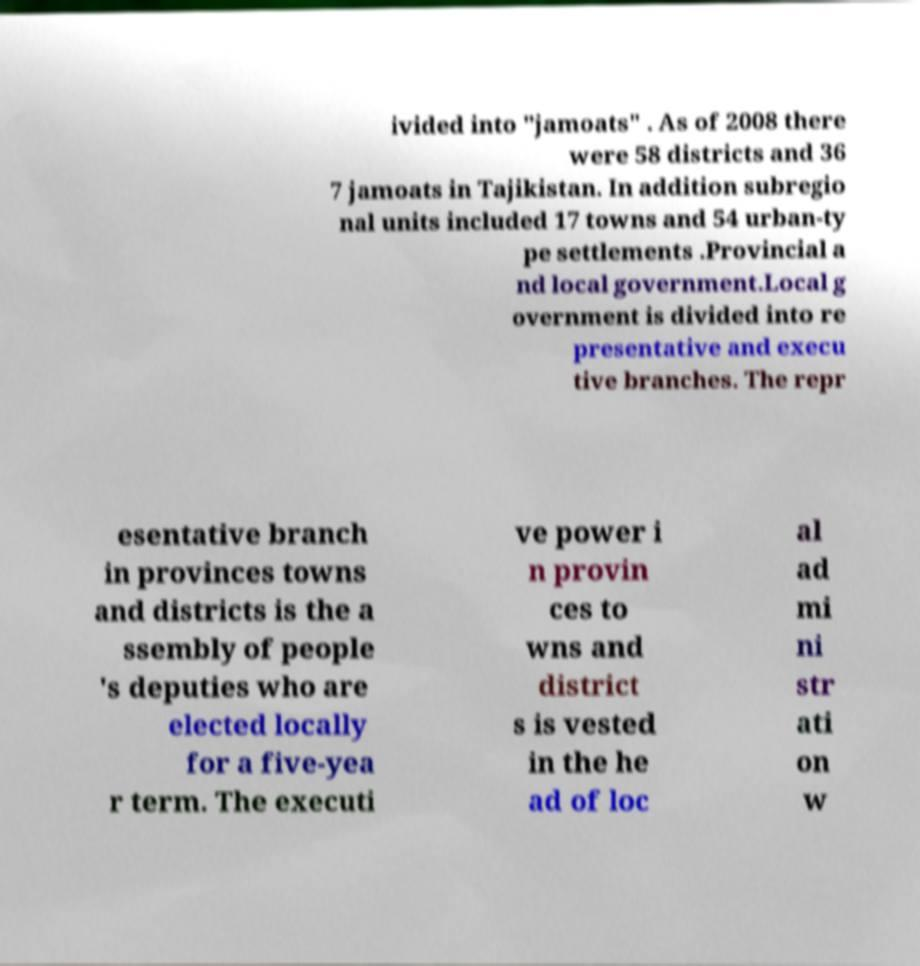Could you extract and type out the text from this image? ivided into "jamoats" . As of 2008 there were 58 districts and 36 7 jamoats in Tajikistan. In addition subregio nal units included 17 towns and 54 urban-ty pe settlements .Provincial a nd local government.Local g overnment is divided into re presentative and execu tive branches. The repr esentative branch in provinces towns and districts is the a ssembly of people 's deputies who are elected locally for a five-yea r term. The executi ve power i n provin ces to wns and district s is vested in the he ad of loc al ad mi ni str ati on w 